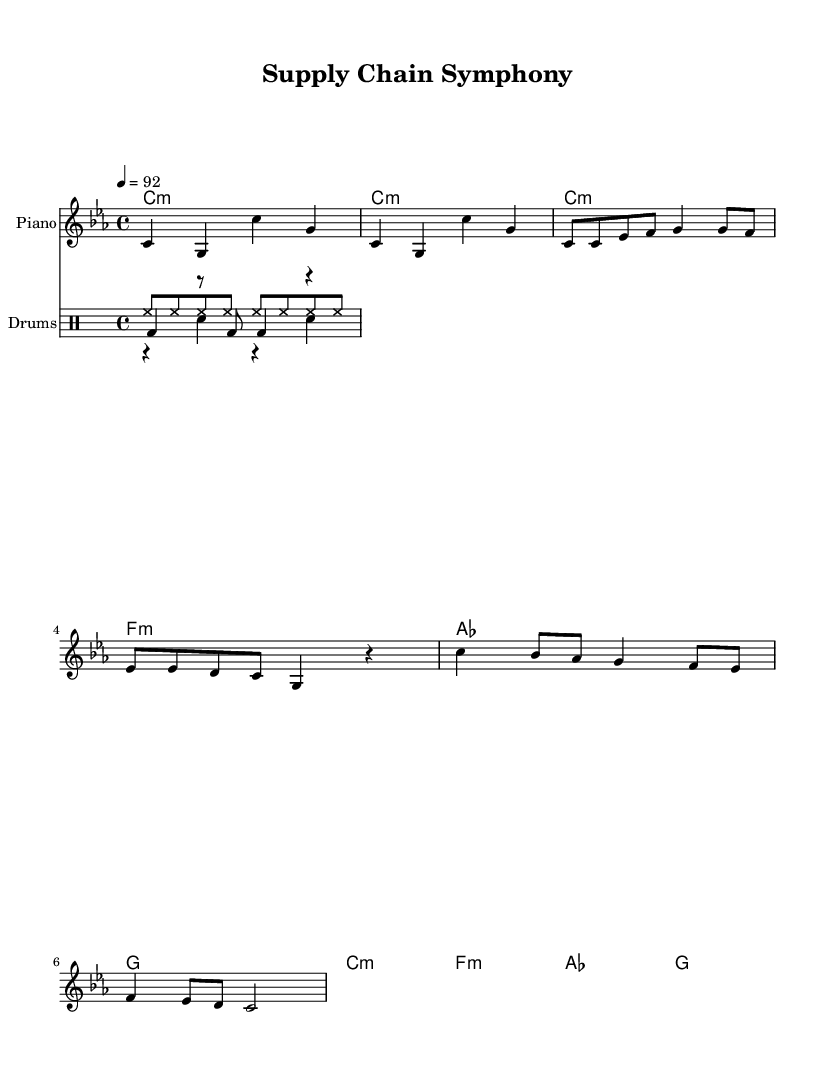What is the key signature of this music? The key signature is C minor, which has three flats (B♭, E♭, A♭). You can find the key signature indicated at the beginning of the piece.
Answer: C minor What is the time signature of this music? The time signature is 4/4, which indicates that there are four beats in a measure and the quarter note gets one beat. This information is displayed next to the key signature at the beginning of the sheet music.
Answer: 4/4 What is the tempo marking in this music? The tempo marking indicates a speed of 92 beats per minute (bpm), expressed as "4 = 92." This is typically found at the beginning under the global settings for tempo.
Answer: 92 How many bars are in the verse section? The verse section consists of 8 bars, which can be determined by counting the measures written in the melody notation marked for the verse.
Answer: 8 What rhythmic pattern is used for the hi-hat? The hi-hat pattern consists of steady eighth notes, repeated through the measure. This is evident by looking at the drum staff, where the hihat is notated.
Answer: Eighth notes What is the lyrical theme of this rap? The lyrical theme focuses on building relationships with suppliers and negotiating deals, as indicated by the content of the lyrics provided under the melody.
Answer: Building relationships What kind of musical structure is represented in this rap? The structure consists of an intro, verse, and chorus, which is a common format in rap music. You can identify this by the distinct sections labeled in the score.
Answer: Intro, verse, chorus 